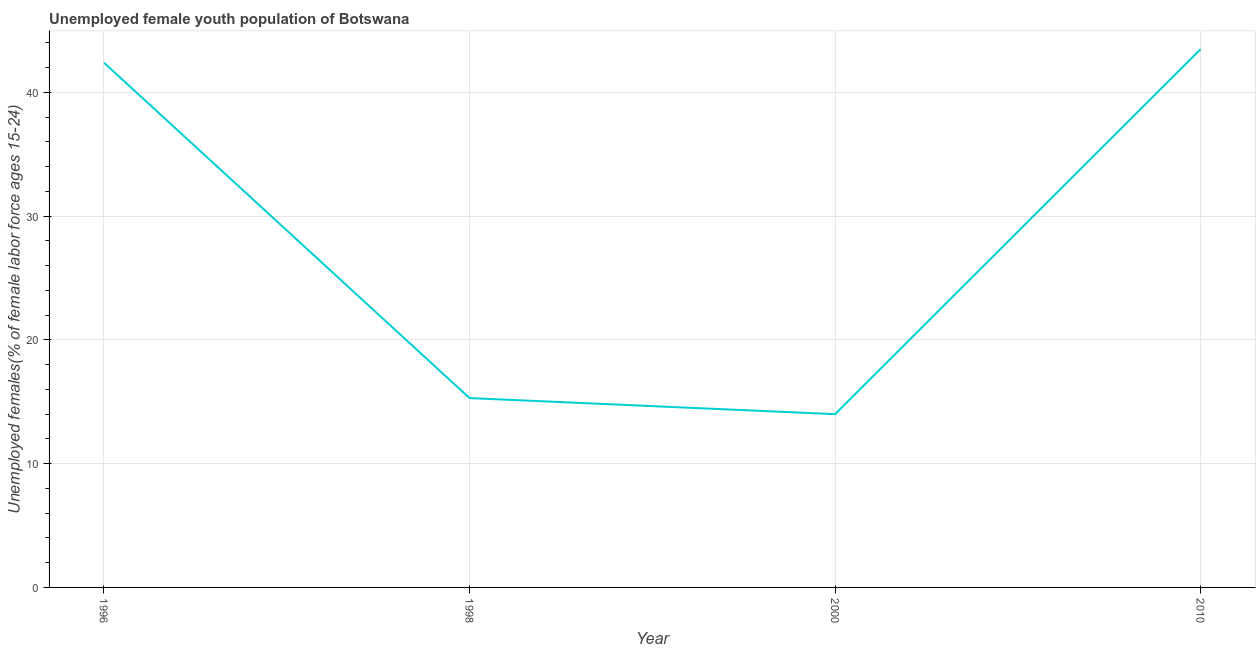What is the unemployed female youth in 2010?
Your answer should be compact. 43.5. Across all years, what is the maximum unemployed female youth?
Provide a succinct answer. 43.5. Across all years, what is the minimum unemployed female youth?
Provide a short and direct response. 14. What is the sum of the unemployed female youth?
Offer a very short reply. 115.2. What is the difference between the unemployed female youth in 1998 and 2010?
Your answer should be very brief. -28.2. What is the average unemployed female youth per year?
Your response must be concise. 28.8. What is the median unemployed female youth?
Provide a short and direct response. 28.85. Do a majority of the years between 2010 and 1996 (inclusive) have unemployed female youth greater than 42 %?
Make the answer very short. Yes. What is the ratio of the unemployed female youth in 1998 to that in 2010?
Your answer should be compact. 0.35. What is the difference between the highest and the second highest unemployed female youth?
Offer a very short reply. 1.1. Is the sum of the unemployed female youth in 2000 and 2010 greater than the maximum unemployed female youth across all years?
Give a very brief answer. Yes. What is the difference between the highest and the lowest unemployed female youth?
Ensure brevity in your answer.  29.5. In how many years, is the unemployed female youth greater than the average unemployed female youth taken over all years?
Your response must be concise. 2. Does the unemployed female youth monotonically increase over the years?
Offer a very short reply. No. How many years are there in the graph?
Give a very brief answer. 4. Are the values on the major ticks of Y-axis written in scientific E-notation?
Your answer should be compact. No. Does the graph contain grids?
Provide a short and direct response. Yes. What is the title of the graph?
Ensure brevity in your answer.  Unemployed female youth population of Botswana. What is the label or title of the X-axis?
Make the answer very short. Year. What is the label or title of the Y-axis?
Your response must be concise. Unemployed females(% of female labor force ages 15-24). What is the Unemployed females(% of female labor force ages 15-24) of 1996?
Your response must be concise. 42.4. What is the Unemployed females(% of female labor force ages 15-24) in 1998?
Your answer should be very brief. 15.3. What is the Unemployed females(% of female labor force ages 15-24) in 2000?
Ensure brevity in your answer.  14. What is the Unemployed females(% of female labor force ages 15-24) of 2010?
Give a very brief answer. 43.5. What is the difference between the Unemployed females(% of female labor force ages 15-24) in 1996 and 1998?
Give a very brief answer. 27.1. What is the difference between the Unemployed females(% of female labor force ages 15-24) in 1996 and 2000?
Your answer should be very brief. 28.4. What is the difference between the Unemployed females(% of female labor force ages 15-24) in 1998 and 2000?
Provide a short and direct response. 1.3. What is the difference between the Unemployed females(% of female labor force ages 15-24) in 1998 and 2010?
Your answer should be compact. -28.2. What is the difference between the Unemployed females(% of female labor force ages 15-24) in 2000 and 2010?
Make the answer very short. -29.5. What is the ratio of the Unemployed females(% of female labor force ages 15-24) in 1996 to that in 1998?
Your response must be concise. 2.77. What is the ratio of the Unemployed females(% of female labor force ages 15-24) in 1996 to that in 2000?
Provide a short and direct response. 3.03. What is the ratio of the Unemployed females(% of female labor force ages 15-24) in 1996 to that in 2010?
Keep it short and to the point. 0.97. What is the ratio of the Unemployed females(% of female labor force ages 15-24) in 1998 to that in 2000?
Offer a terse response. 1.09. What is the ratio of the Unemployed females(% of female labor force ages 15-24) in 1998 to that in 2010?
Your response must be concise. 0.35. What is the ratio of the Unemployed females(% of female labor force ages 15-24) in 2000 to that in 2010?
Make the answer very short. 0.32. 